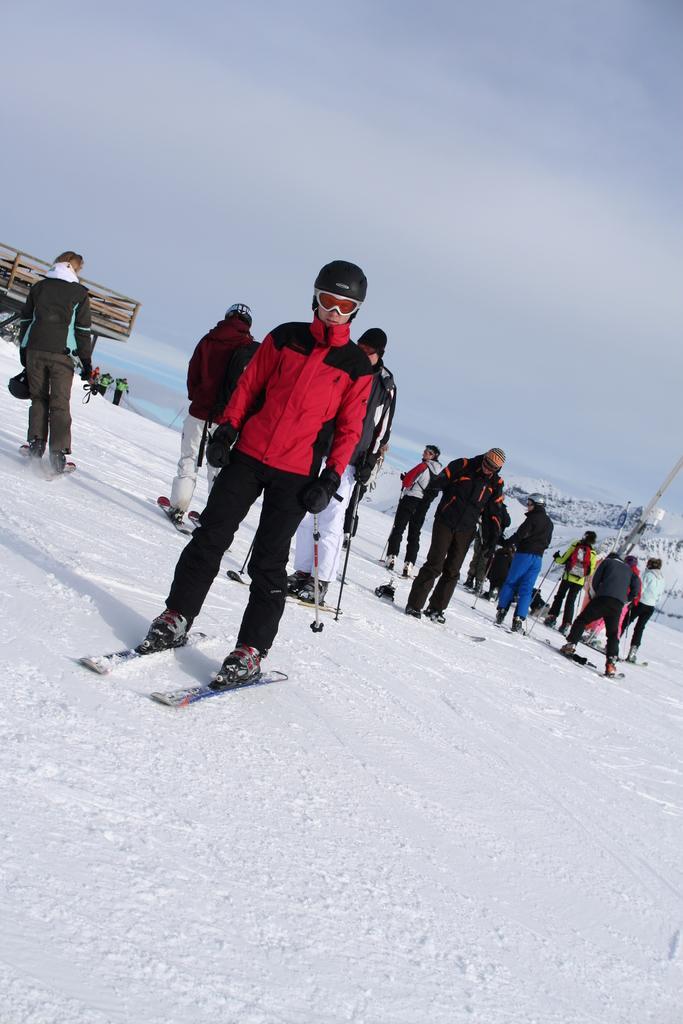Please provide a concise description of this image. In the center of the image we can see a man skiing on the snow. In the background there are people and we can see hills. At the top there is sky. 